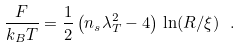<formula> <loc_0><loc_0><loc_500><loc_500>\frac { F } { k _ { B } T } = \frac { 1 } { 2 } \left ( n _ { s } \lambda _ { T } ^ { 2 } - 4 \right ) \, \ln ( R / \xi ) \ .</formula> 